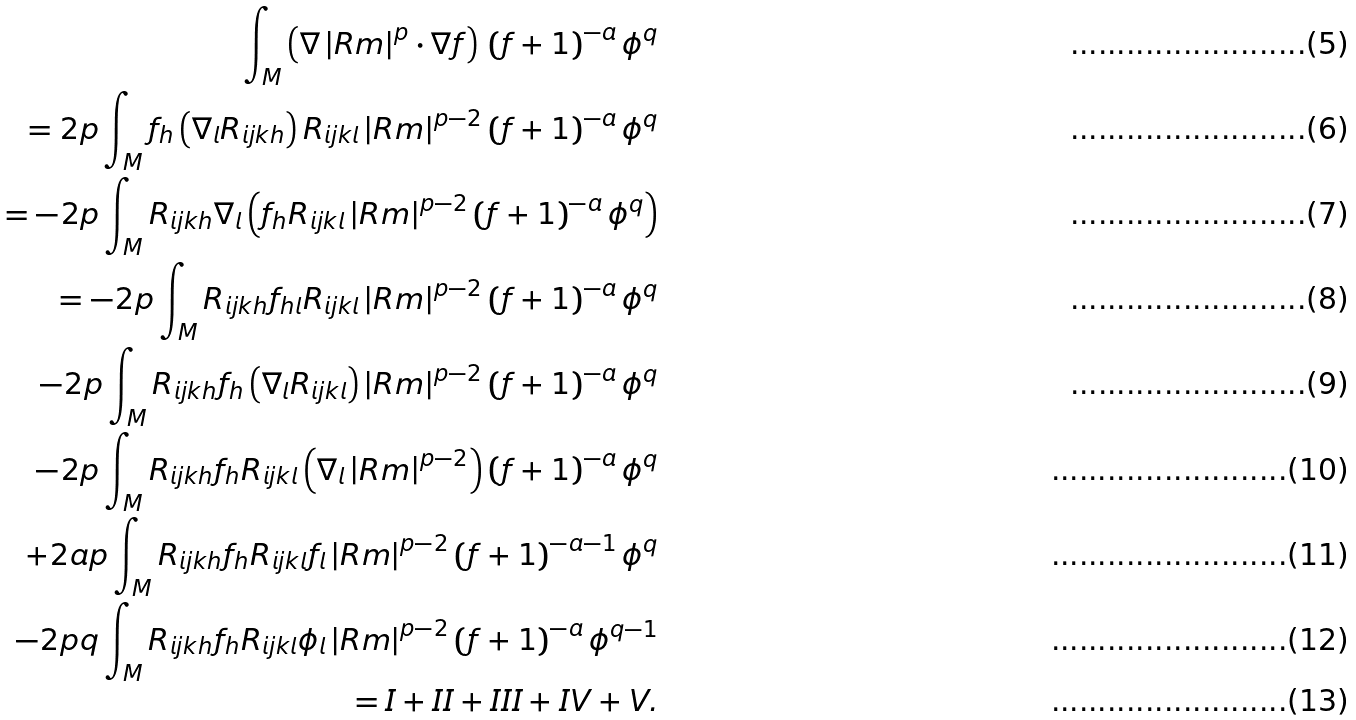Convert formula to latex. <formula><loc_0><loc_0><loc_500><loc_500>\int _ { M } \left ( \nabla \left | R m \right | ^ { p } \cdot \nabla f \right ) \, \left ( f + 1 \right ) ^ { - a } \phi ^ { q } \\ = 2 p \int _ { M } f _ { h } \left ( \nabla _ { l } R _ { i j k h } \right ) R _ { i j k l } \left | R m \right | ^ { p - 2 } \left ( f + 1 \right ) ^ { - a } \phi ^ { q } \\ = - 2 p \int _ { M } R _ { i j k h } \nabla _ { l } \left ( f _ { h } R _ { i j k l } \left | R m \right | ^ { p - 2 } \left ( f + 1 \right ) ^ { - a } \phi ^ { q } \right ) \\ = - 2 p \int _ { M } R _ { i j k h } f _ { h l } R _ { i j k l } \left | R m \right | ^ { p - 2 } \left ( f + 1 \right ) ^ { - a } \phi ^ { q } \\ - 2 p \int _ { M } R _ { i j k h } f _ { h } \left ( \nabla _ { l } R _ { i j k l } \right ) \left | R m \right | ^ { p - 2 } \left ( f + 1 \right ) ^ { - a } \phi ^ { q } \\ - 2 p \int _ { M } R _ { i j k h } f _ { h } R _ { i j k l } \left ( \nabla _ { l } \left | R m \right | ^ { p - 2 } \right ) \left ( f + 1 \right ) ^ { - a } \phi ^ { q } \\ + 2 a p \int _ { M } R _ { i j k h } f _ { h } R _ { i j k l } f _ { l } \left | R m \right | ^ { p - 2 } \left ( f + 1 \right ) ^ { - a - 1 } \phi ^ { q } \\ - 2 p q \int _ { M } R _ { i j k h } f _ { h } R _ { i j k l } \phi _ { l } \left | R m \right | ^ { p - 2 } \left ( f + 1 \right ) ^ { - a } \phi ^ { q - 1 } \\ = I + I I + I I I + I V + V .</formula> 